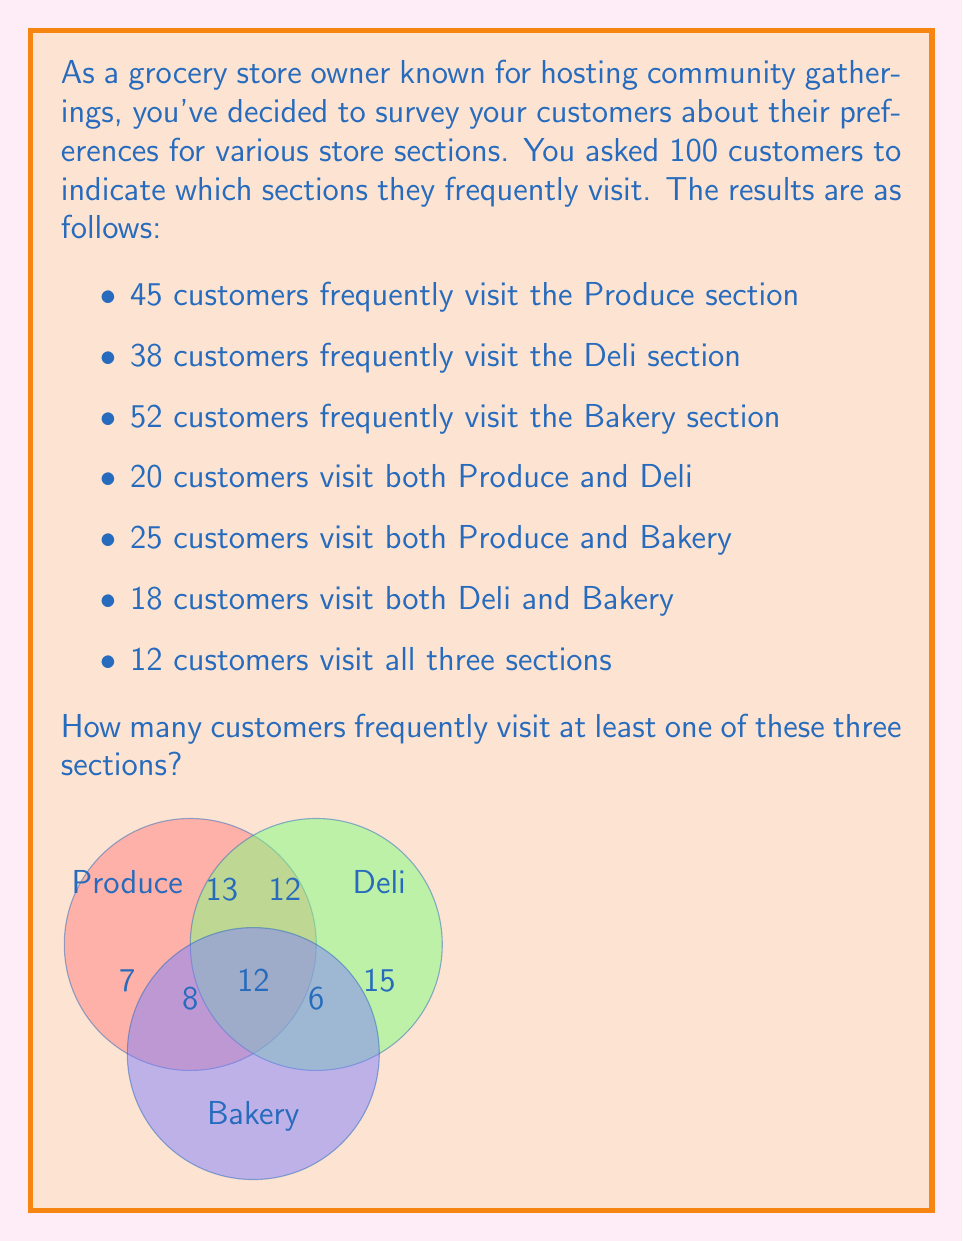Solve this math problem. Let's solve this problem using the Inclusion-Exclusion Principle for three sets:

1) Let's define our sets:
   P: customers who visit Produce
   D: customers who visit Deli
   B: customers who visit Bakery

2) We're given:
   $|P| = 45$, $|D| = 38$, $|B| = 52$
   $|P \cap D| = 20$, $|P \cap B| = 25$, $|D \cap B| = 18$
   $|P \cap D \cap B| = 12$

3) The Inclusion-Exclusion Principle states:
   $|P \cup D \cup B| = |P| + |D| + |B| - |P \cap D| - |P \cap B| - |D \cap B| + |P \cap D \cap B|$

4) Let's substitute our values:
   $|P \cup D \cup B| = 45 + 38 + 52 - 20 - 25 - 18 + 12$

5) Now we can calculate:
   $|P \cup D \cup B| = 135 - 63 + 12 = 84$

Therefore, 84 customers frequently visit at least one of these three sections.
Answer: 84 customers 